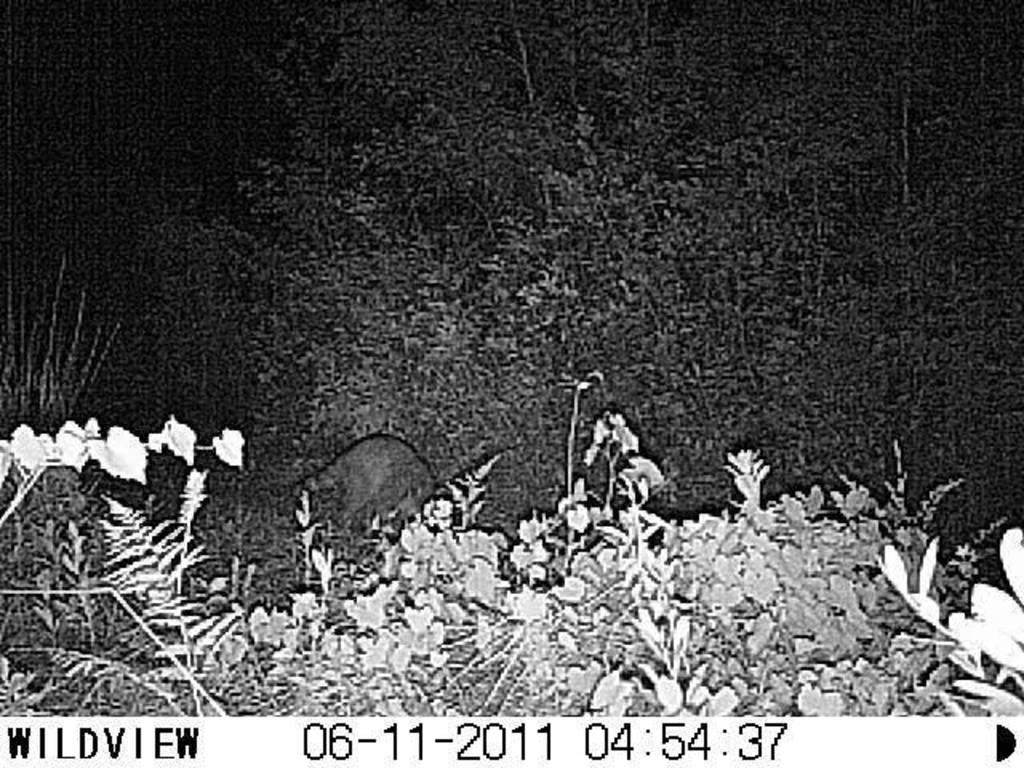What type of vegetation is present on the ground in the image? There are plants on the ground in the image. What kind of living creature can be seen in the image? There is an animal in the image. What other natural elements are visible in the image? There are trees in the image. How is the image presented in terms of color? The image is black and white. What else can be seen in the image besides the plants, animal, and trees? There is text visible in the image. What type of breakfast is being served on the tray in the image? There is no tray or breakfast present in the image. What is located on the top of the animal in the image? There is no mention of anything being on top of the animal in the image. 